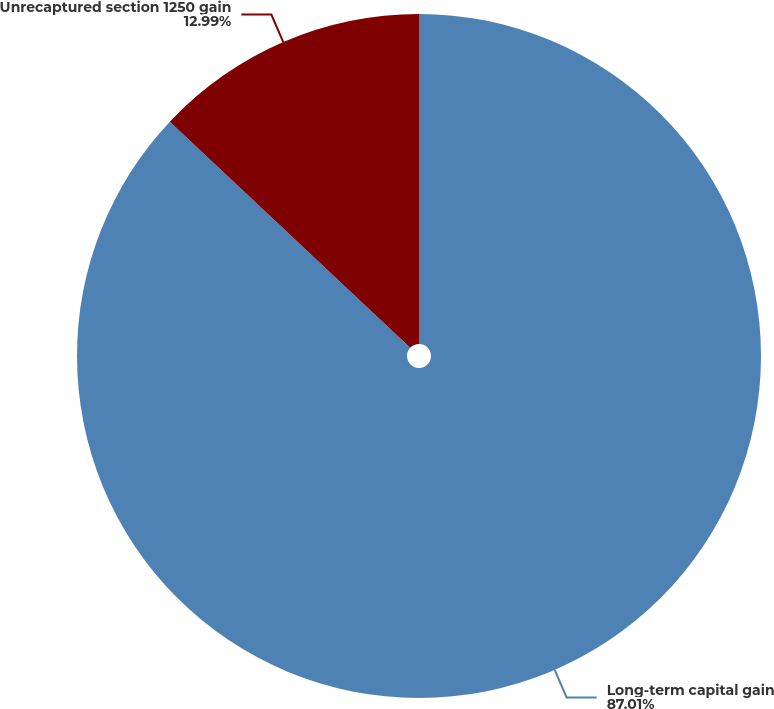Convert chart to OTSL. <chart><loc_0><loc_0><loc_500><loc_500><pie_chart><fcel>Long-term capital gain<fcel>Unrecaptured section 1250 gain<nl><fcel>87.01%<fcel>12.99%<nl></chart> 